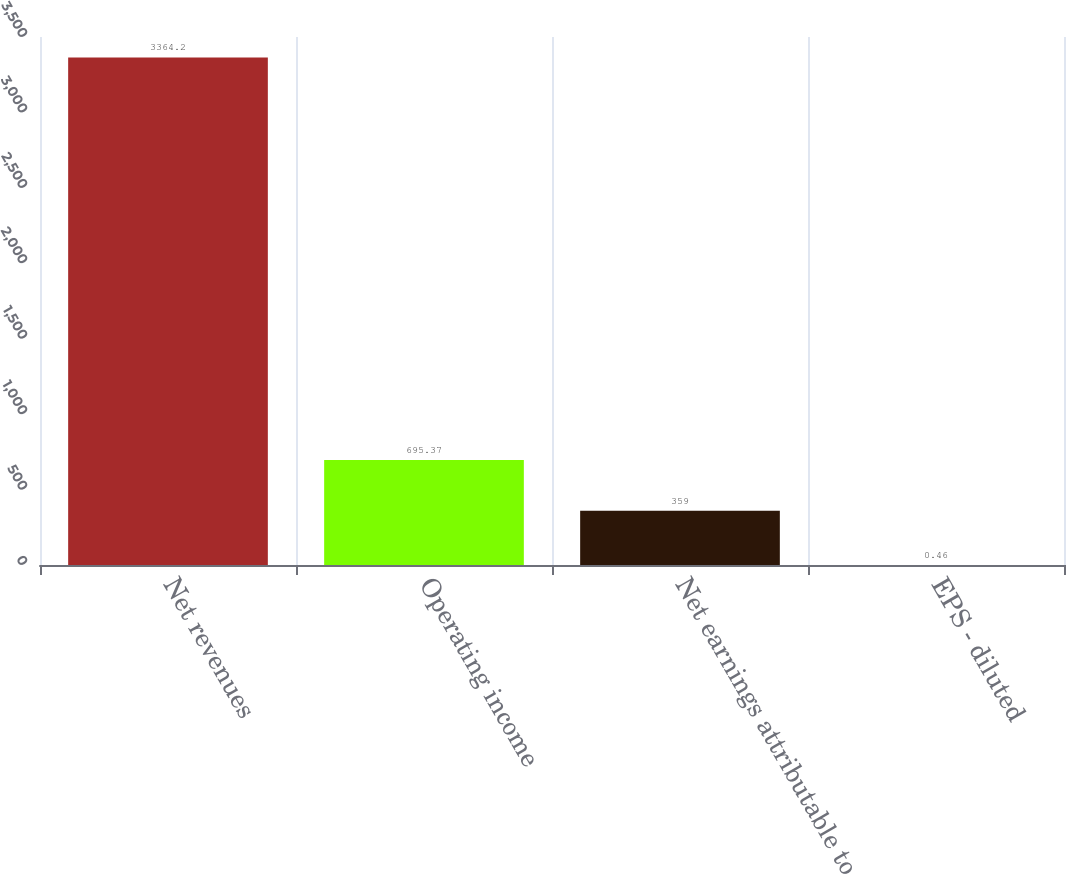<chart> <loc_0><loc_0><loc_500><loc_500><bar_chart><fcel>Net revenues<fcel>Operating income<fcel>Net earnings attributable to<fcel>EPS - diluted<nl><fcel>3364.2<fcel>695.37<fcel>359<fcel>0.46<nl></chart> 